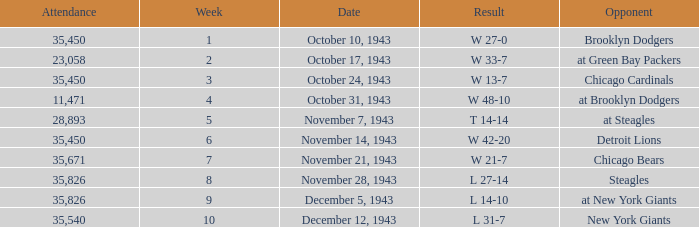How many attendances have 9 as the week? 1.0. 